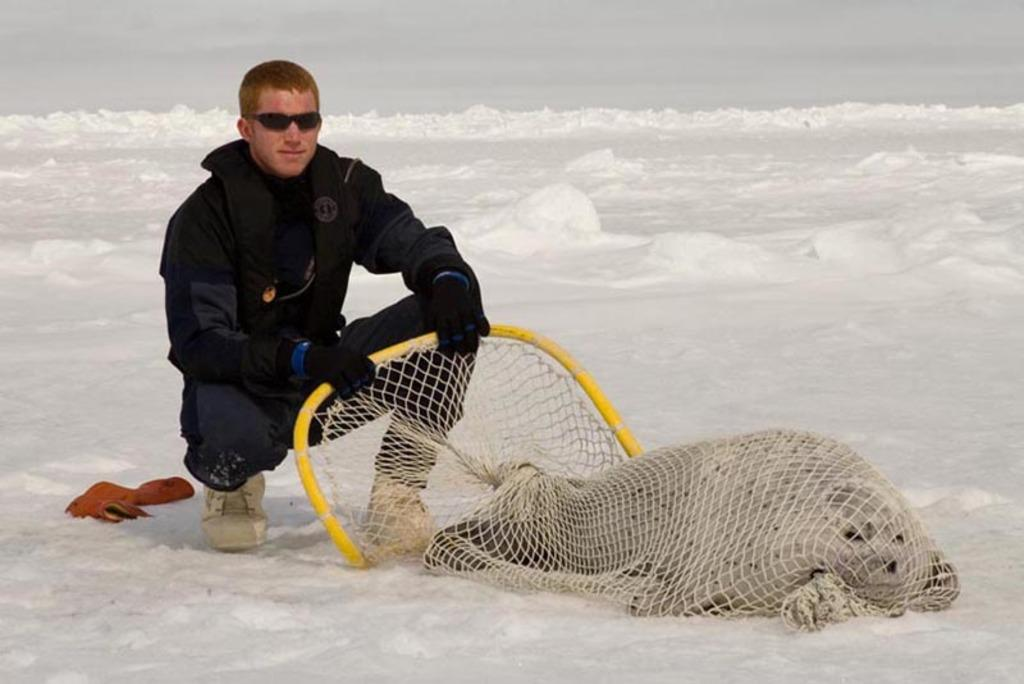What is the person in the image sitting on? The person is sitting on mounds of snow in the image. What is the person holding in the image? The person is holding an animal that was caught in a nest. What decision did the person make before sitting on the snow in the image? There is no information about any decision made by the person before sitting on the snow in the image. 